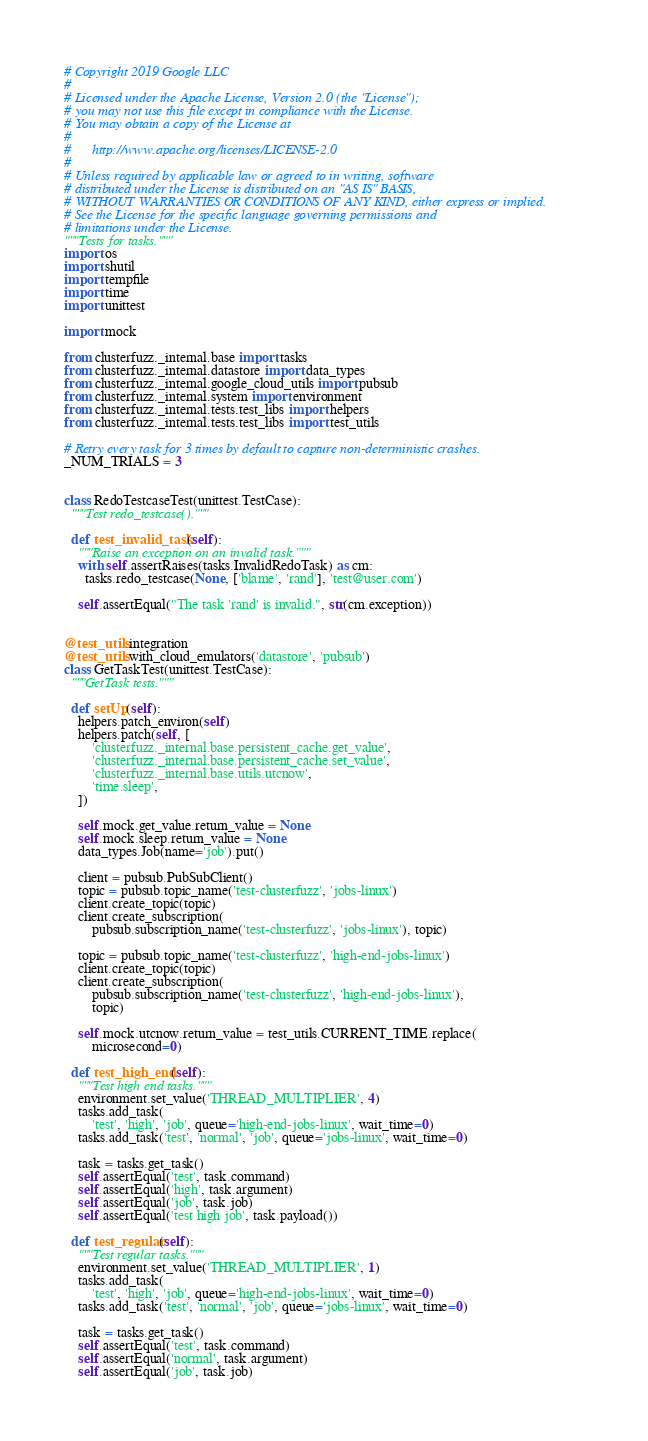Convert code to text. <code><loc_0><loc_0><loc_500><loc_500><_Python_># Copyright 2019 Google LLC
#
# Licensed under the Apache License, Version 2.0 (the "License");
# you may not use this file except in compliance with the License.
# You may obtain a copy of the License at
#
#      http://www.apache.org/licenses/LICENSE-2.0
#
# Unless required by applicable law or agreed to in writing, software
# distributed under the License is distributed on an "AS IS" BASIS,
# WITHOUT WARRANTIES OR CONDITIONS OF ANY KIND, either express or implied.
# See the License for the specific language governing permissions and
# limitations under the License.
"""Tests for tasks."""
import os
import shutil
import tempfile
import time
import unittest

import mock

from clusterfuzz._internal.base import tasks
from clusterfuzz._internal.datastore import data_types
from clusterfuzz._internal.google_cloud_utils import pubsub
from clusterfuzz._internal.system import environment
from clusterfuzz._internal.tests.test_libs import helpers
from clusterfuzz._internal.tests.test_libs import test_utils

# Retry every task for 3 times by default to capture non-deterministic crashes.
_NUM_TRIALS = 3


class RedoTestcaseTest(unittest.TestCase):
  """Test redo_testcase()."""

  def test_invalid_task(self):
    """Raise an exception on an invalid task."""
    with self.assertRaises(tasks.InvalidRedoTask) as cm:
      tasks.redo_testcase(None, ['blame', 'rand'], 'test@user.com')

    self.assertEqual("The task 'rand' is invalid.", str(cm.exception))


@test_utils.integration
@test_utils.with_cloud_emulators('datastore', 'pubsub')
class GetTaskTest(unittest.TestCase):
  """GetTask tests."""

  def setUp(self):
    helpers.patch_environ(self)
    helpers.patch(self, [
        'clusterfuzz._internal.base.persistent_cache.get_value',
        'clusterfuzz._internal.base.persistent_cache.set_value',
        'clusterfuzz._internal.base.utils.utcnow',
        'time.sleep',
    ])

    self.mock.get_value.return_value = None
    self.mock.sleep.return_value = None
    data_types.Job(name='job').put()

    client = pubsub.PubSubClient()
    topic = pubsub.topic_name('test-clusterfuzz', 'jobs-linux')
    client.create_topic(topic)
    client.create_subscription(
        pubsub.subscription_name('test-clusterfuzz', 'jobs-linux'), topic)

    topic = pubsub.topic_name('test-clusterfuzz', 'high-end-jobs-linux')
    client.create_topic(topic)
    client.create_subscription(
        pubsub.subscription_name('test-clusterfuzz', 'high-end-jobs-linux'),
        topic)

    self.mock.utcnow.return_value = test_utils.CURRENT_TIME.replace(
        microsecond=0)

  def test_high_end(self):
    """Test high end tasks."""
    environment.set_value('THREAD_MULTIPLIER', 4)
    tasks.add_task(
        'test', 'high', 'job', queue='high-end-jobs-linux', wait_time=0)
    tasks.add_task('test', 'normal', 'job', queue='jobs-linux', wait_time=0)

    task = tasks.get_task()
    self.assertEqual('test', task.command)
    self.assertEqual('high', task.argument)
    self.assertEqual('job', task.job)
    self.assertEqual('test high job', task.payload())

  def test_regular(self):
    """Test regular tasks."""
    environment.set_value('THREAD_MULTIPLIER', 1)
    tasks.add_task(
        'test', 'high', 'job', queue='high-end-jobs-linux', wait_time=0)
    tasks.add_task('test', 'normal', 'job', queue='jobs-linux', wait_time=0)

    task = tasks.get_task()
    self.assertEqual('test', task.command)
    self.assertEqual('normal', task.argument)
    self.assertEqual('job', task.job)</code> 